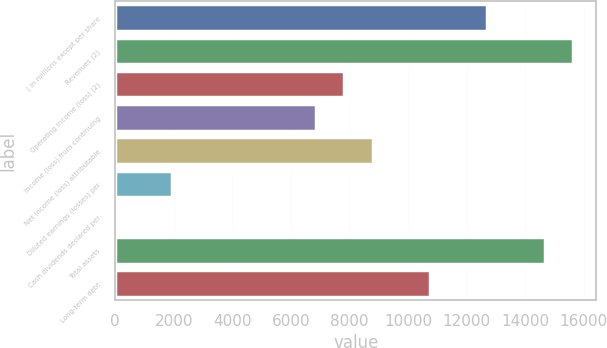Convert chart to OTSL. <chart><loc_0><loc_0><loc_500><loc_500><bar_chart><fcel>( in millions except per share<fcel>Revenues (2)<fcel>Operating income (loss) (2)<fcel>Income (loss) from continuing<fcel>Net income (loss) attributable<fcel>Diluted earnings (losses) per<fcel>Cash dividends declared per<fcel>Total assets<fcel>Long-term debt<nl><fcel>12711.3<fcel>15644.6<fcel>7822.4<fcel>6844.62<fcel>8800.18<fcel>1955.72<fcel>0.16<fcel>14666.9<fcel>10755.7<nl></chart> 